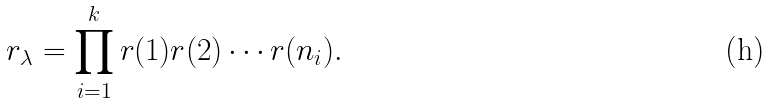<formula> <loc_0><loc_0><loc_500><loc_500>r _ { \lambda } = \prod _ { i = 1 } ^ { k } r ( 1 ) r ( 2 ) \cdots r ( n _ { i } ) .</formula> 